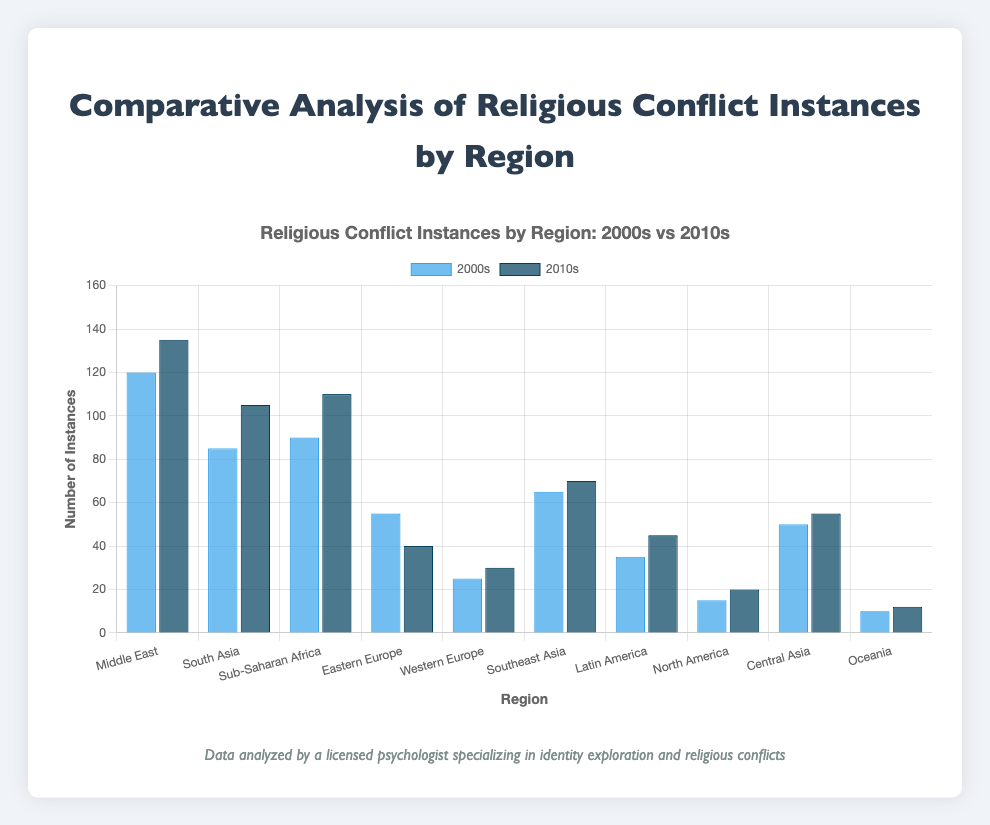What's the region with the highest number of religious conflict instances in the 2010s? The region with the highest number of religious conflict instances in the 2010s can be identified by finding the tallest dark blue bar. The Middle East has the highest number of instances, totaling 135.
Answer: Middle East How many religious conflict instances were recorded in the Middle East in the 2000s and 2010s combined? To find the total number of instances in the Middle East for both decades, sum the counts for the 2000s and 2010s: 120 (2000s) + 135 (2010s) = 255.
Answer: 255 Which region saw a decrease in the number of religious conflict instances from the 2000s to the 2010s? A decrease in conflict instances would be shown by a taller blue bar (2000s) compared to the dark blue bar (2010s). Eastern Europe saw a decrease from 55 in the 2000s to 40 in the 2010s.
Answer: Eastern Europe What's the average number of religious conflict instances in Sub-Saharan Africa across the two decades? To find the average, add the conflict instances for the 2000s and 2010s and then divide by 2: (90 + 110) / 2 = 100.
Answer: 100 Which region has the smallest increase in religious conflict instances from the 2000s to the 2010s? The smallest increase is identified by the difference between the blue and dark blue bars being the smallest positive value. Oceania has an increase of only 2 instances (from 10 in the 2000s to 12 in the 2010s).
Answer: Oceania What is the total number of religious conflict instances for all regions in the 2000s? Sum all instances in the 2000s for each region: 120 + 85 + 90 + 55 + 25 + 65 + 35 + 15 + 50 + 10 = 550.
Answer: 550 Compare the number of religious conflict instances in South Asia and Western Europe in the 2010s. Which region had more instances? To compare, look at the dark blue bars for South Asia and Western Europe in the 2010s. South Asia had 105 instances, while Western Europe had 30, so South Asia had more.
Answer: South Asia What's the percentage increase in religious conflict instances in Latin America from the 2000s to the 2010s? Find the difference between the two decades and then divide by the 2000s value, finally multiply by 100 for the percentage: ((45 - 35) / 35) * 100 = 28.57%.
Answer: 28.57% Which region had almost the same number of religious conflict instances in both decades? A region with almost equal bar heights indicates similar conflict instances across both decades. Southeast Asia had 65 instances in the 2000s and 70 in the 2010s.
Answer: Southeast Asia How many more instances of religious conflict were there in Central Asia in the 2010s compared to North America in the same period? Compare the dark blue bars for both regions in the 2010s. Central Asia had 55 instances, while North America had 20, leading to 55 - 20 = 35 additional instances in Central Asia.
Answer: 35 